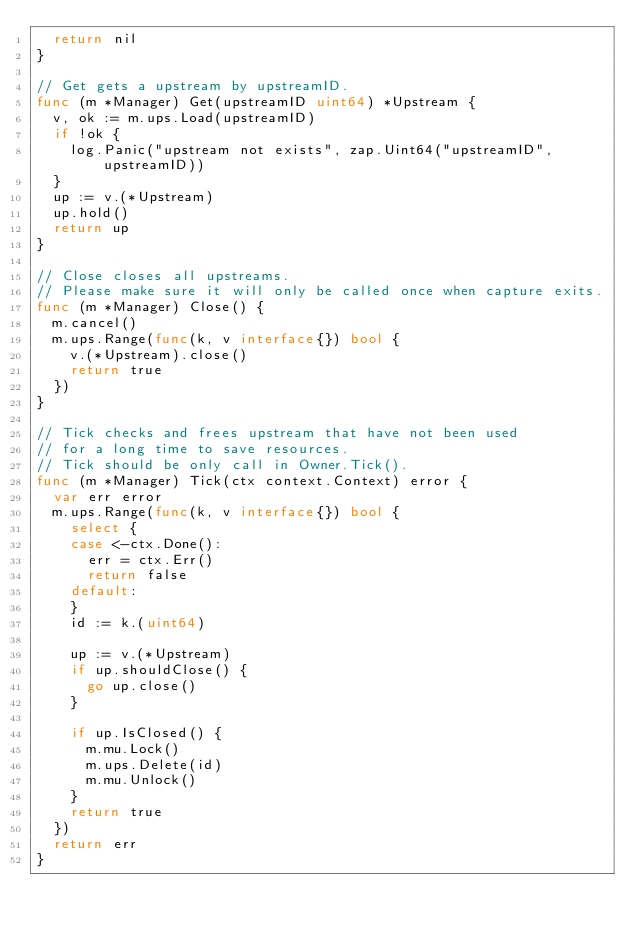Convert code to text. <code><loc_0><loc_0><loc_500><loc_500><_Go_>	return nil
}

// Get gets a upstream by upstreamID.
func (m *Manager) Get(upstreamID uint64) *Upstream {
	v, ok := m.ups.Load(upstreamID)
	if !ok {
		log.Panic("upstream not exists", zap.Uint64("upstreamID", upstreamID))
	}
	up := v.(*Upstream)
	up.hold()
	return up
}

// Close closes all upstreams.
// Please make sure it will only be called once when capture exits.
func (m *Manager) Close() {
	m.cancel()
	m.ups.Range(func(k, v interface{}) bool {
		v.(*Upstream).close()
		return true
	})
}

// Tick checks and frees upstream that have not been used
// for a long time to save resources.
// Tick should be only call in Owner.Tick().
func (m *Manager) Tick(ctx context.Context) error {
	var err error
	m.ups.Range(func(k, v interface{}) bool {
		select {
		case <-ctx.Done():
			err = ctx.Err()
			return false
		default:
		}
		id := k.(uint64)

		up := v.(*Upstream)
		if up.shouldClose() {
			go up.close()
		}

		if up.IsClosed() {
			m.mu.Lock()
			m.ups.Delete(id)
			m.mu.Unlock()
		}
		return true
	})
	return err
}
</code> 